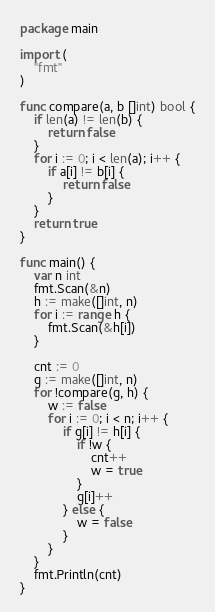<code> <loc_0><loc_0><loc_500><loc_500><_Go_>package main

import (
	"fmt"
)

func compare(a, b []int) bool {
	if len(a) != len(b) {
		return false
	}
	for i := 0; i < len(a); i++ {
		if a[i] != b[i] {
			return false
		}
	}
	return true
}

func main() {
	var n int
	fmt.Scan(&n)
	h := make([]int, n)
	for i := range h {
		fmt.Scan(&h[i])
	}

	cnt := 0
	g := make([]int, n)
	for !compare(g, h) {
		w := false
		for i := 0; i < n; i++ {
			if g[i] != h[i] {
				if !w {
					cnt++
					w = true
				}
				g[i]++
			} else {
				w = false
			}
		}
	}
	fmt.Println(cnt)
}
</code> 